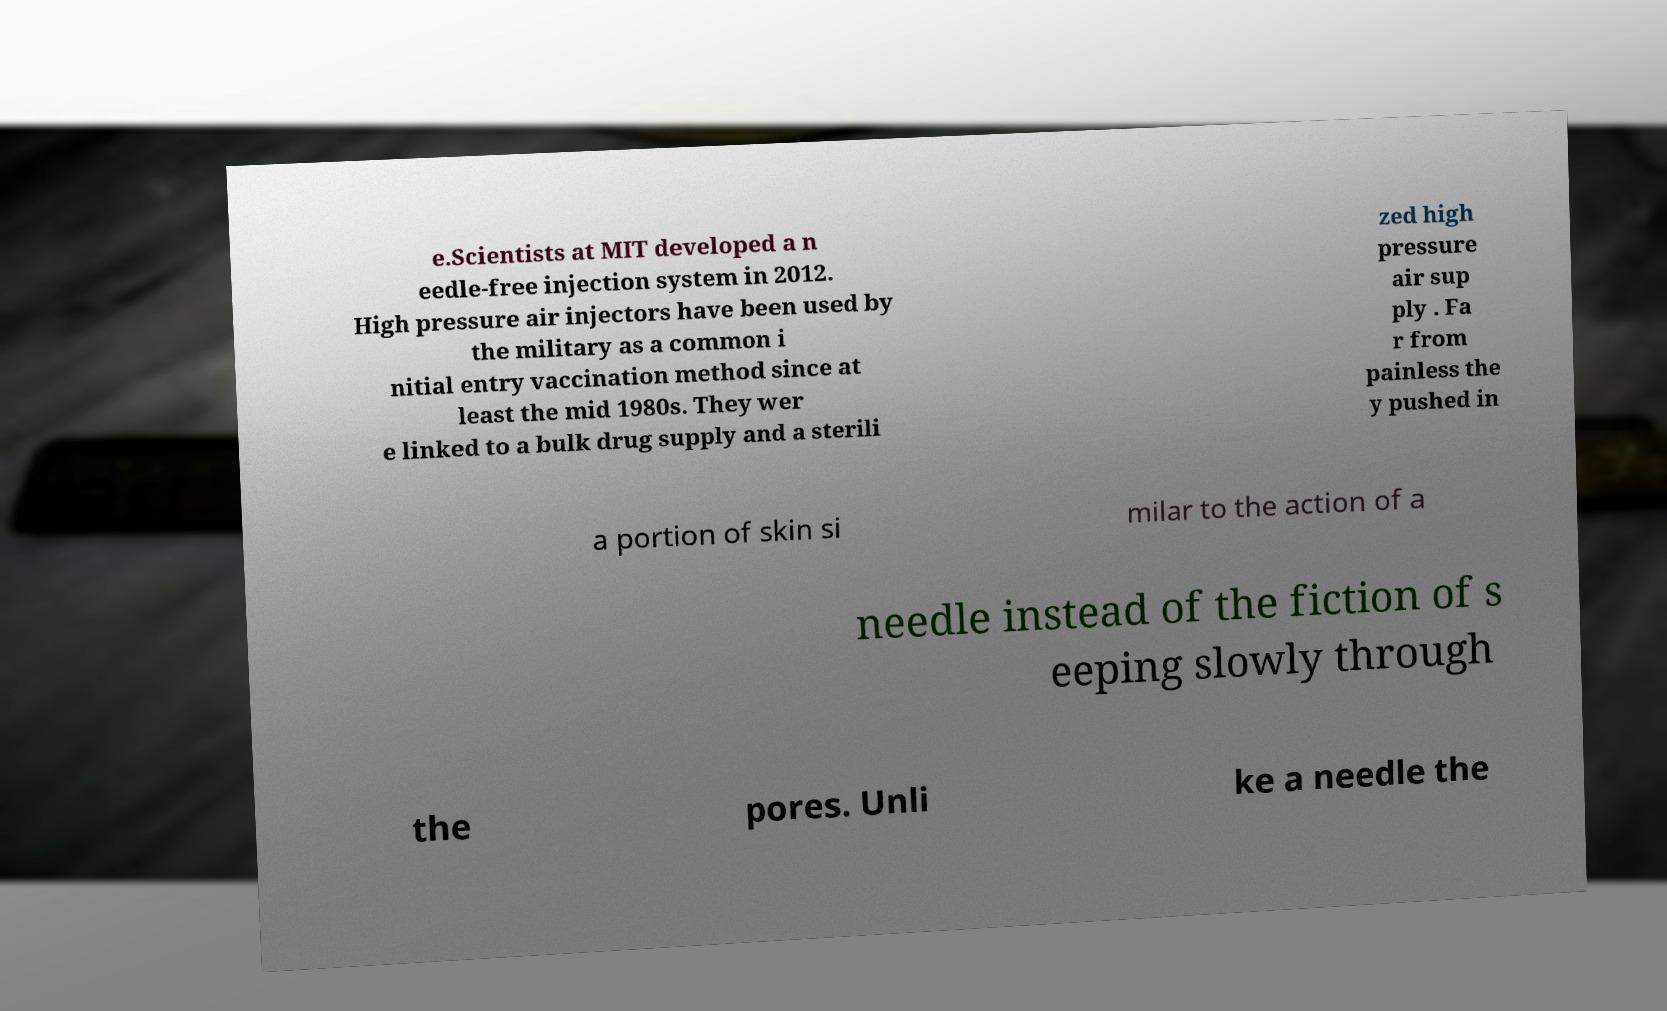Could you assist in decoding the text presented in this image and type it out clearly? e.Scientists at MIT developed a n eedle-free injection system in 2012. High pressure air injectors have been used by the military as a common i nitial entry vaccination method since at least the mid 1980s. They wer e linked to a bulk drug supply and a sterili zed high pressure air sup ply . Fa r from painless the y pushed in a portion of skin si milar to the action of a needle instead of the fiction of s eeping slowly through the pores. Unli ke a needle the 